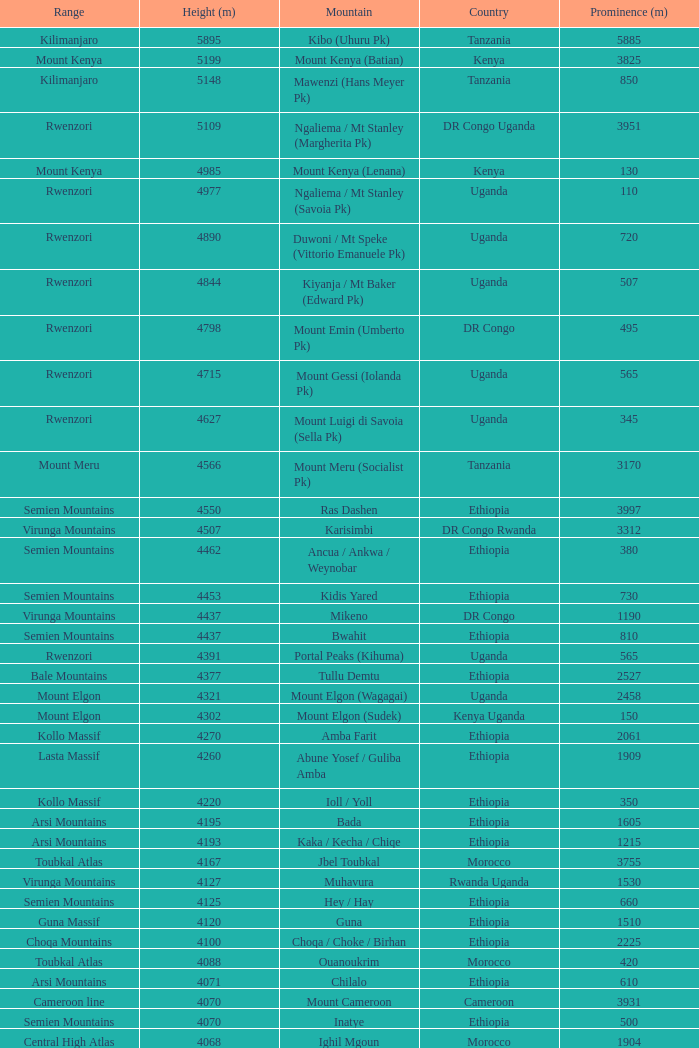Which Country has a Prominence (m) smaller than 1540, and a Height (m) smaller than 3530, and a Range of virunga mountains, and a Mountain of nyiragongo? DR Congo. 